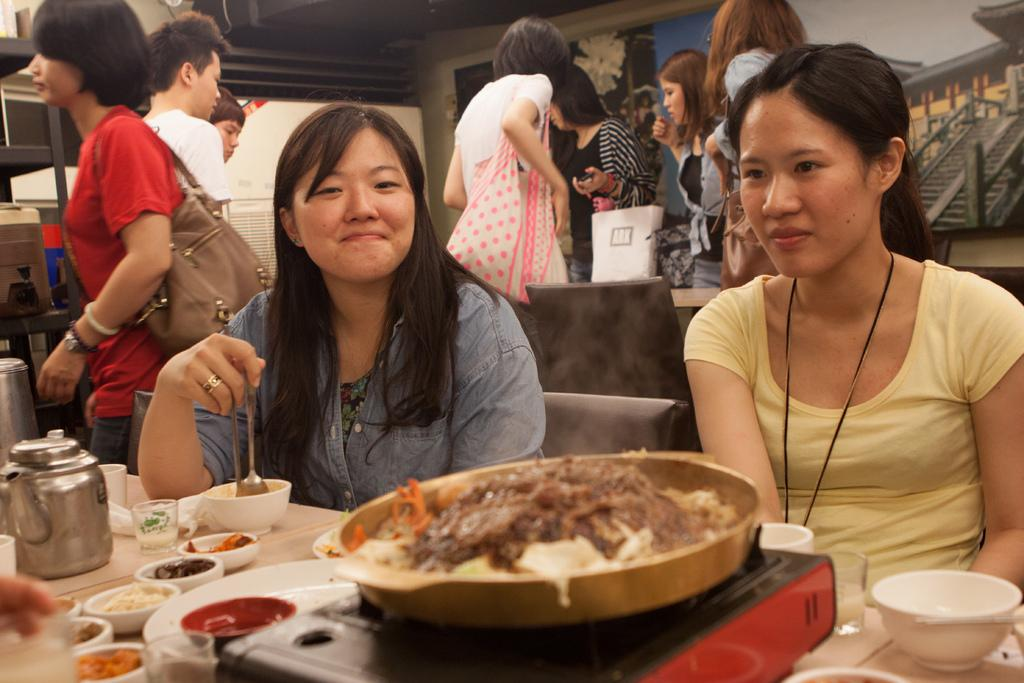How many women are in the image? There are two women in the image. Can you describe the setting of the image? There are other people in the background of the image, and there is a table in the image. What is on the table in the image? There is food on the table. What type of kitty can be seen playing with a hand in the wilderness in the image? There is no kitty, hand, or wilderness present in the image. 